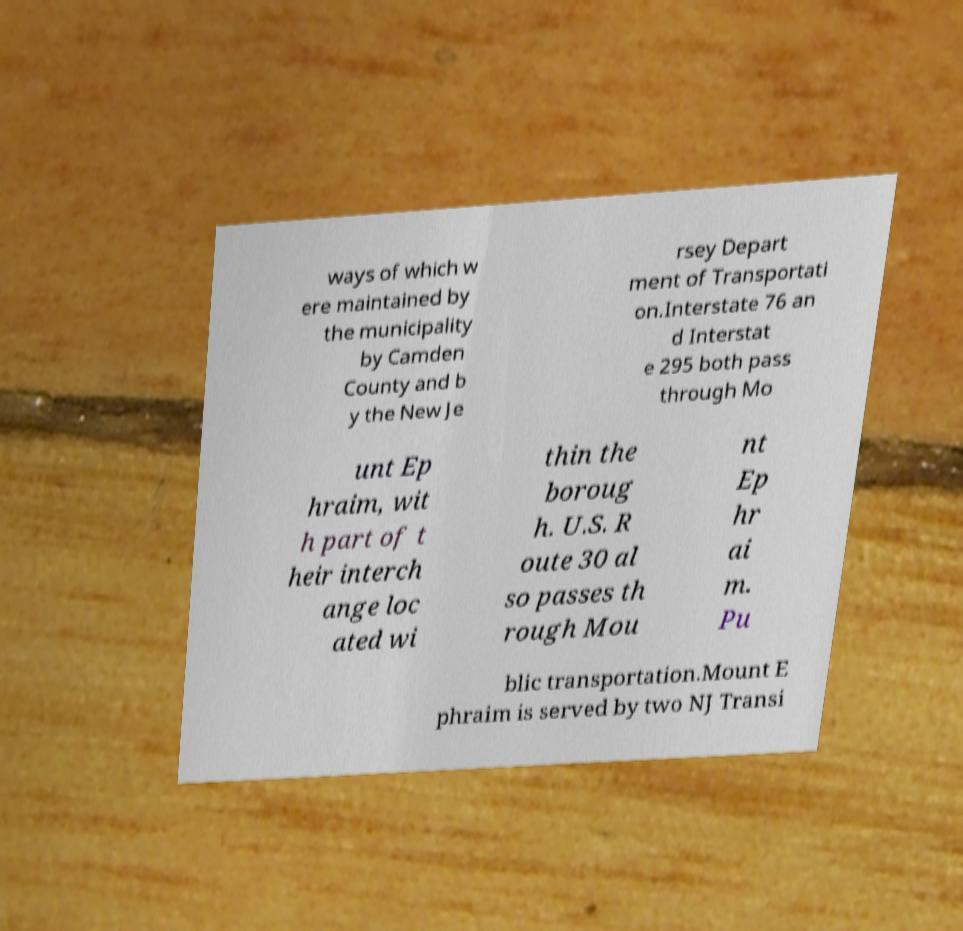Please read and relay the text visible in this image. What does it say? ways of which w ere maintained by the municipality by Camden County and b y the New Je rsey Depart ment of Transportati on.Interstate 76 an d Interstat e 295 both pass through Mo unt Ep hraim, wit h part of t heir interch ange loc ated wi thin the boroug h. U.S. R oute 30 al so passes th rough Mou nt Ep hr ai m. Pu blic transportation.Mount E phraim is served by two NJ Transi 